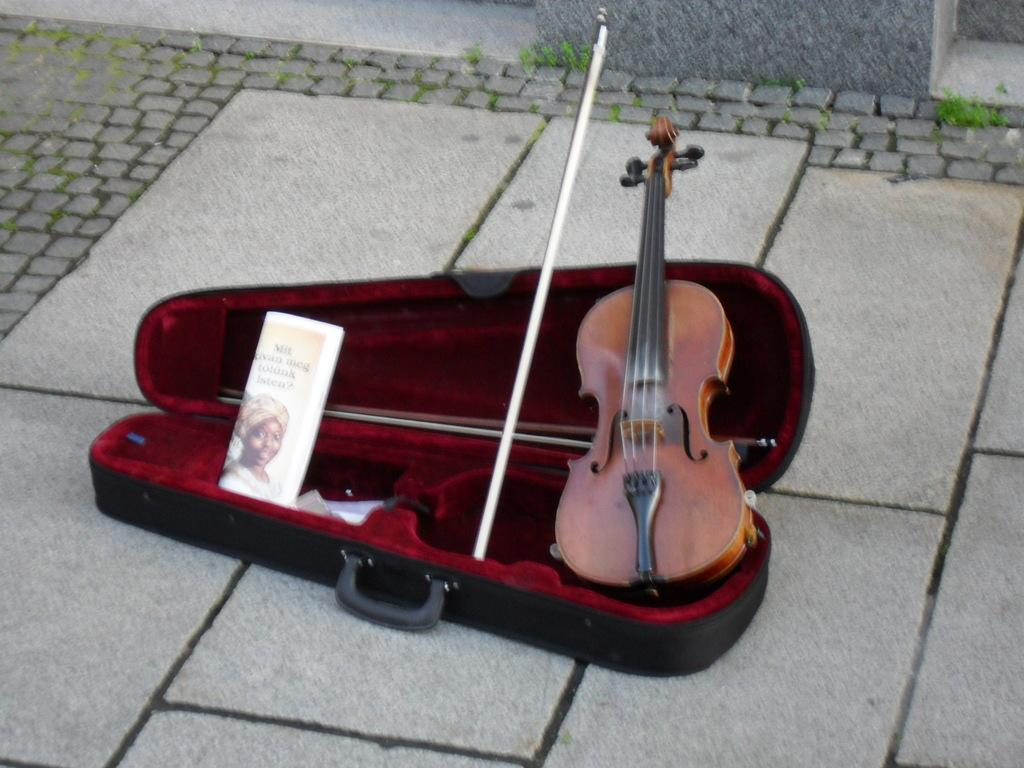What object is the main focus of the image? There is a box in the image. What else can be seen in the image besides the box? There is paper and a guitar in the image. How many flowers are on the guitar in the image? There are no flowers present in the image, and the guitar does not have any flowers on it. 